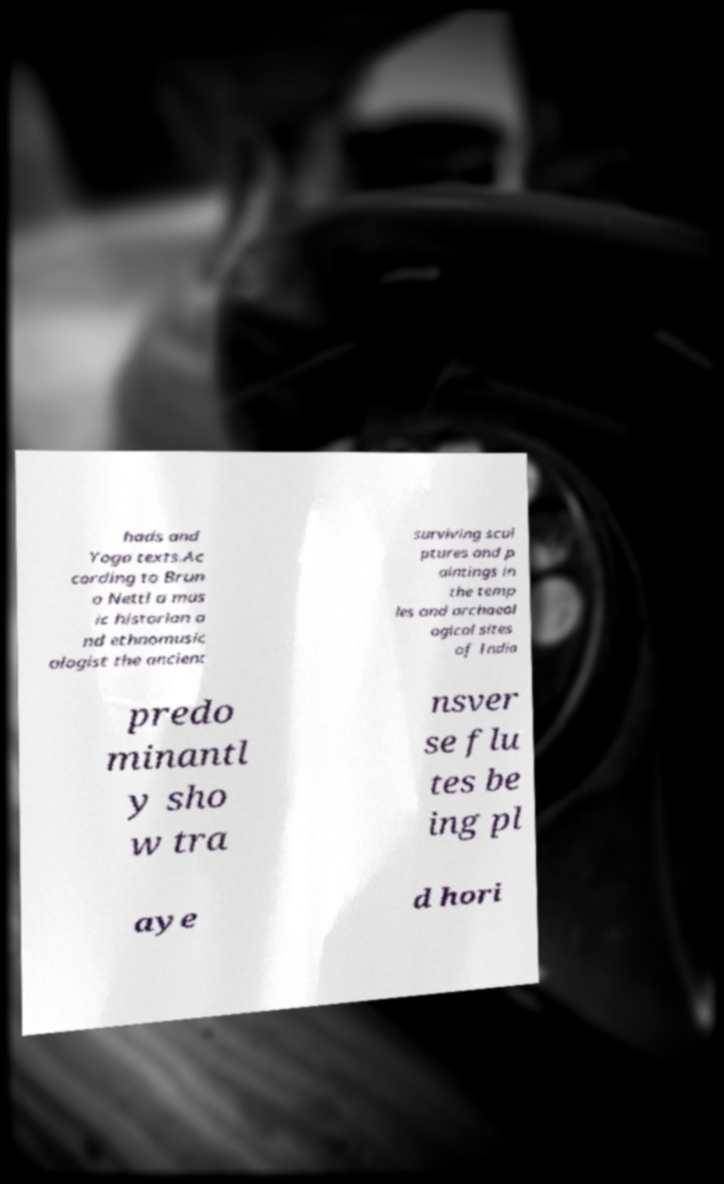Please read and relay the text visible in this image. What does it say? hads and Yoga texts.Ac cording to Brun o Nettl a mus ic historian a nd ethnomusic ologist the ancient surviving scul ptures and p aintings in the temp les and archaeol ogical sites of India predo minantl y sho w tra nsver se flu tes be ing pl aye d hori 